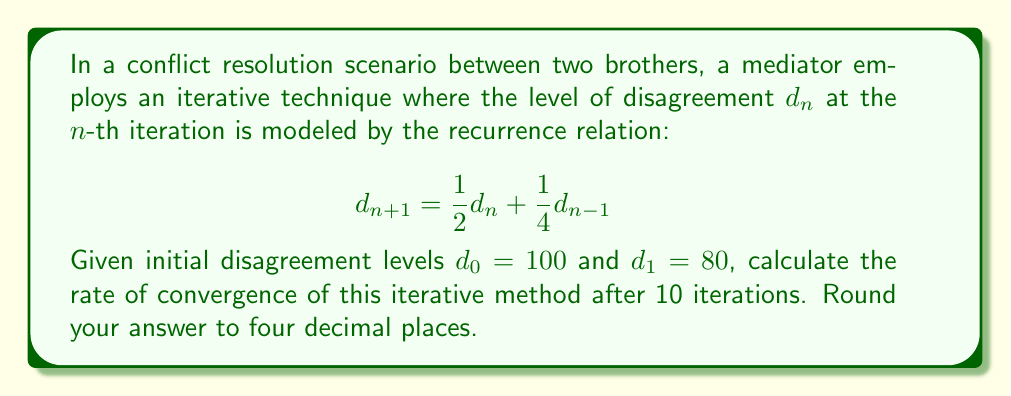Solve this math problem. To calculate the rate of convergence, we need to follow these steps:

1) First, we need to calculate the disagreement levels for 10 iterations using the given recurrence relation.

2) The general formula for the rate of convergence $R$ is:

   $$R = \lim_{n \to \infty} \frac{|d_{n+1} - d^*|}{|d_n - d^*|^p}$$

   where $d^*$ is the limit of the sequence (if it exists) and $p$ is the order of convergence.

3) For practical purposes, we can estimate $R$ using:

   $$R \approx \frac{|d_{n+1} - d_n|}{|d_n - d_{n-1}|^p}$$

4) We'll assume linear convergence (p = 1) for this problem.

5) Let's calculate the first 10 iterations:

   $d_0 = 100$
   $d_1 = 80$
   $d_2 = \frac{1}{2}(80) + \frac{1}{4}(100) = 65$
   $d_3 = \frac{1}{2}(65) + \frac{1}{4}(80) = 52.5$
   $d_4 = \frac{1}{2}(52.5) + \frac{1}{4}(65) = 42.5$
   $d_5 = \frac{1}{2}(42.5) + \frac{1}{4}(52.5) = 34.375$
   $d_6 = \frac{1}{2}(34.375) + \frac{1}{4}(42.5) = 27.8125$
   $d_7 = \frac{1}{2}(27.8125) + \frac{1}{4}(34.375) = 22.5$
   $d_8 = \frac{1}{2}(22.5) + \frac{1}{4}(27.8125) = 18.203125$
   $d_9 = \frac{1}{2}(18.203125) + \frac{1}{4}(22.5) = 14.7265625$
   $d_{10} = \frac{1}{2}(14.7265625) + \frac{1}{4}(18.203125) = 11.9140625$

6) Now we can estimate R using the values at n = 9 and n = 10:

   $$R \approx \frac{|d_{10} - d_9|}{|d_9 - d_8|} = \frac{|11.9140625 - 14.7265625|}{|14.7265625 - 18.203125|} = 0.8090$$

7) Rounding to four decimal places, we get 0.8090.
Answer: 0.8090 